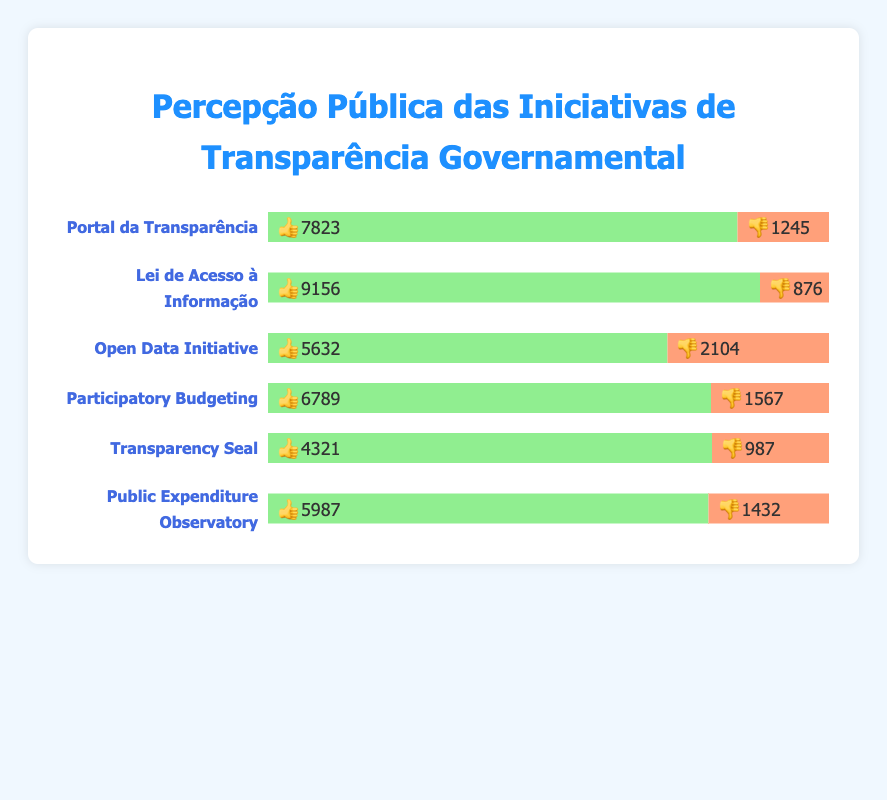Which initiative received the highest number of 👍? The initiative "Lei de Acesso à Informação" received the highest number of thumbs up with 9156. To determine this, compare the thumbs-up counts of all initiatives.
Answer: Lei de Acesso à Informação Which initiative received the highest number of 👎? The initiative "Open Data Initiative" received the highest number of thumbs down with 2104. To determine this, compare the thumbs-down counts of all initiatives.
Answer: Open Data Initiative What is the combined number of 👍 and 👎 for "Portal da Transparência"? The thumbs up are 7823 and thumbs down are 1245 for "Portal da Transparência". Adding these together: 7823 + 1245 = 9068.
Answer: 9068 Which initiative has the smallest percentage of 👎 relative to its total feedback? "Lei de Acesso à Informação" has 9156 👍 and 876 👎. The total feedback is 10032. The percentage of 👎 is (876/10032) * 100 ≈ 8.7%, which is the smallest percentage compared to other initiatives.
Answer: Lei de Acesso à Informação How does the number of 👍 for "Participatory Budgeting" compare to "Public Expenditure Observatory"? "Participatory Budgeting" has 6789 👍 and "Public Expenditure Observatory" has 5987 👍. "Participatory Budgeting" has more thumbs up.
Answer: Participatory Budgeting What is the average number of 👍 across all initiatives? Summing the thumbs-up counts for all initiatives: 7823 + 9156 + 5632 + 6789 + 4321 + 5987 = 39708. There are 6 initiatives, so the average is 39708/6 = 6618.
Answer: 6618 What is the difference in the number of 👎 between "Transparency Seal" and "Open Data Initiative"? "Transparency Seal" has 987 👎 and "Open Data Initiative" has 2104 👎. The difference is 2104 - 987 = 1117.
Answer: 1117 Which initiative has the closest number of 👍 to "Portal da Transparência"? "Participatory Budgeting" with 6789 👍 is the closest to "Portal da Transparência" which has 7823 👍. The difference is 7823 - 6789 = 1034, whereas all other differences are greater.
Answer: Participatory Budgeting Which initiative has a higher percentage of 👍, "Transparency Seal" or "Public Expenditure Observatory"? "Transparency Seal" has 4321 👍 out of 5308 feedbacks and "Public Expenditure Observatory" has 5987 👍 out of 7419 feedbacks. Calculating the percentages: (4321/5308) * 100 ≈ 81.4% and (5987/7419) * 100 ≈ 80.7%. "Transparency Seal" has a higher percentage.
Answer: Transparency Seal Order the initiatives from highest to lowest number of 👎. Comparing the numbers: "Open Data Initiative" (2104), "Participatory Budgeting" (1567), "Public Expenditure Observatory" (1432), "Portal da Transparência" (1245), "Transparency Seal" (987), "Lei de Acesso à Informação" (876). The order is: Open Data Initiative > Participatory Budgeting > Public Expenditure Observatory > Portal da Transparência > Transparency Seal > Lei de Acesso à Informação.
Answer: Open Data Initiative > Participatory Budgeting > Public Expenditure Observatory > Portal da Transparência > Transparency Seal > Lei de Acesso à Informação 